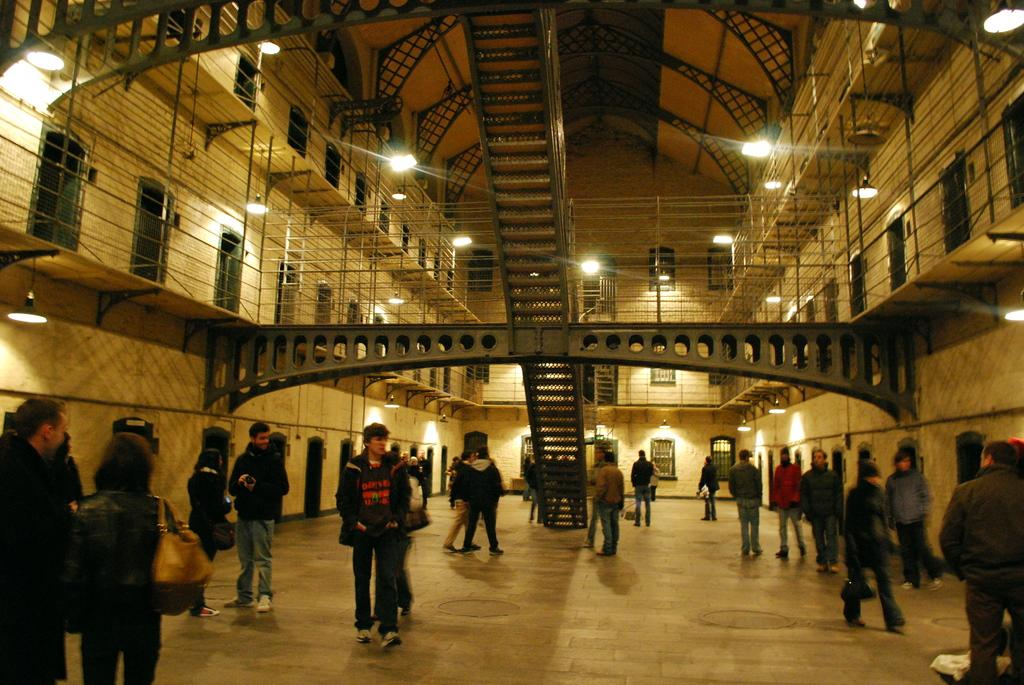How many people are in the image? There are people in the image, but the exact number is not specified. What are the people wearing in the image? The people are wearing jackets in the image. What can be seen through the windows in the image? The information provided does not specify what can be seen through the windows. What architectural features are present in the image? Poles and pillars are present in the image. What is on the roof in the image? There are lights on the roof in the image. Can you tell me how many bikes are parked on the road in the image? There is no mention of bikes or a road in the image, so it is not possible to answer this question. 